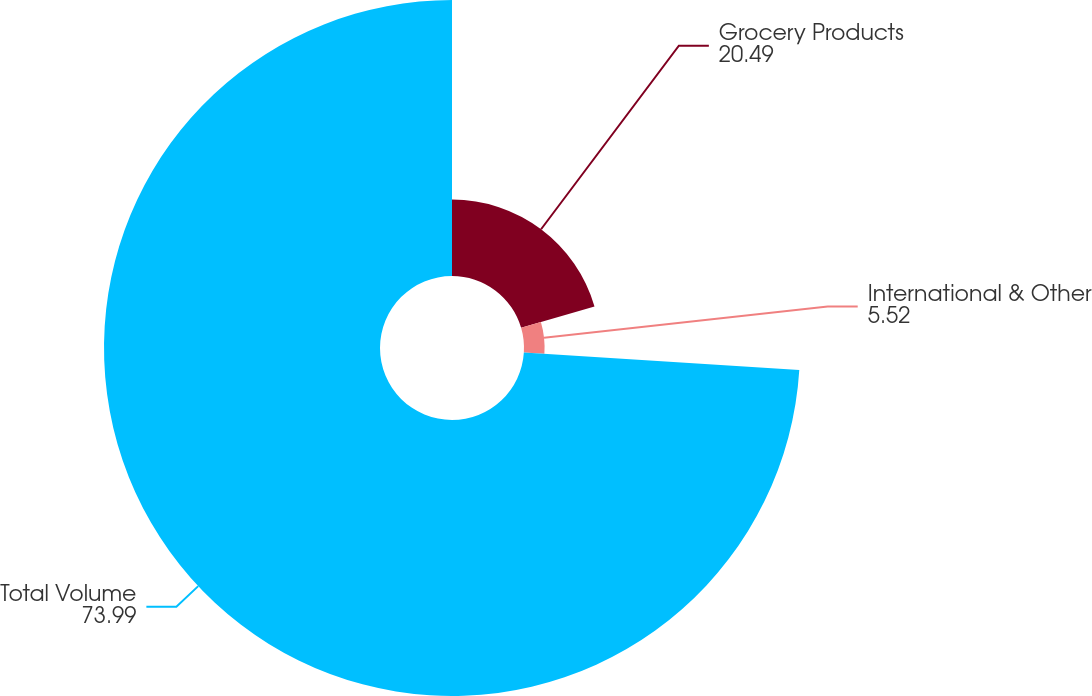<chart> <loc_0><loc_0><loc_500><loc_500><pie_chart><fcel>Grocery Products<fcel>International & Other<fcel>Total Volume<nl><fcel>20.49%<fcel>5.52%<fcel>73.99%<nl></chart> 